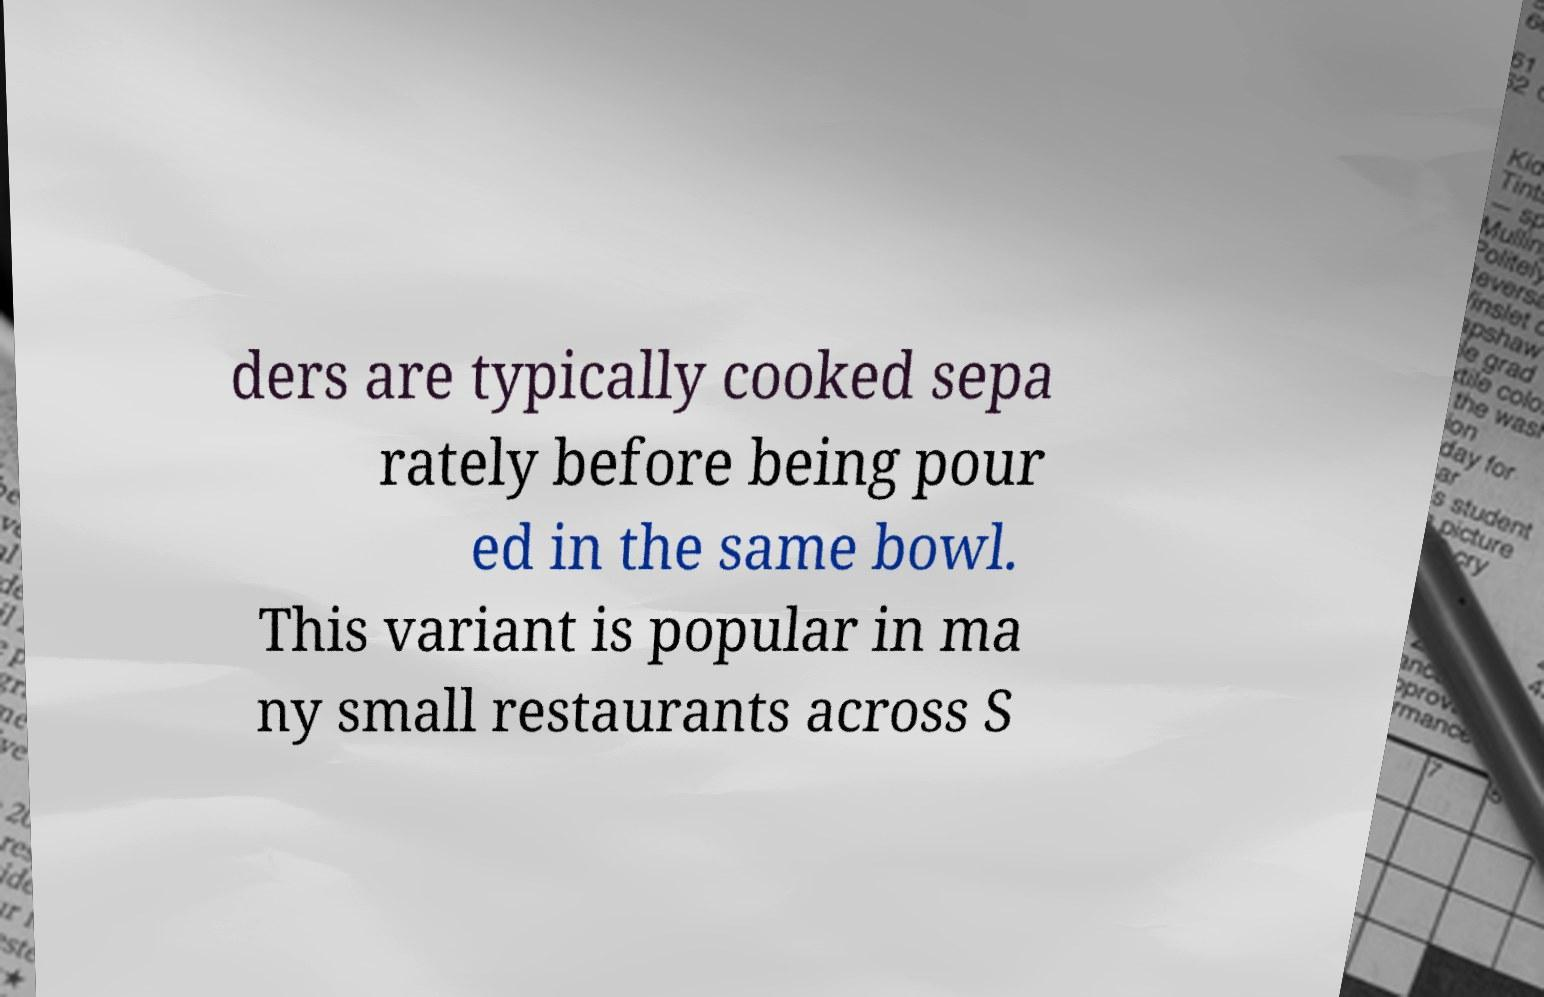Could you assist in decoding the text presented in this image and type it out clearly? ders are typically cooked sepa rately before being pour ed in the same bowl. This variant is popular in ma ny small restaurants across S 